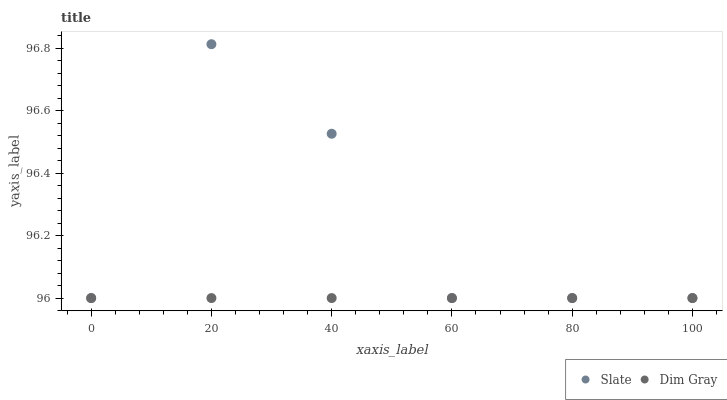Does Dim Gray have the minimum area under the curve?
Answer yes or no. Yes. Does Slate have the maximum area under the curve?
Answer yes or no. Yes. Does Dim Gray have the maximum area under the curve?
Answer yes or no. No. Is Dim Gray the smoothest?
Answer yes or no. Yes. Is Slate the roughest?
Answer yes or no. Yes. Is Dim Gray the roughest?
Answer yes or no. No. Does Slate have the lowest value?
Answer yes or no. Yes. Does Slate have the highest value?
Answer yes or no. Yes. Does Dim Gray have the highest value?
Answer yes or no. No. Does Dim Gray intersect Slate?
Answer yes or no. Yes. Is Dim Gray less than Slate?
Answer yes or no. No. Is Dim Gray greater than Slate?
Answer yes or no. No. 